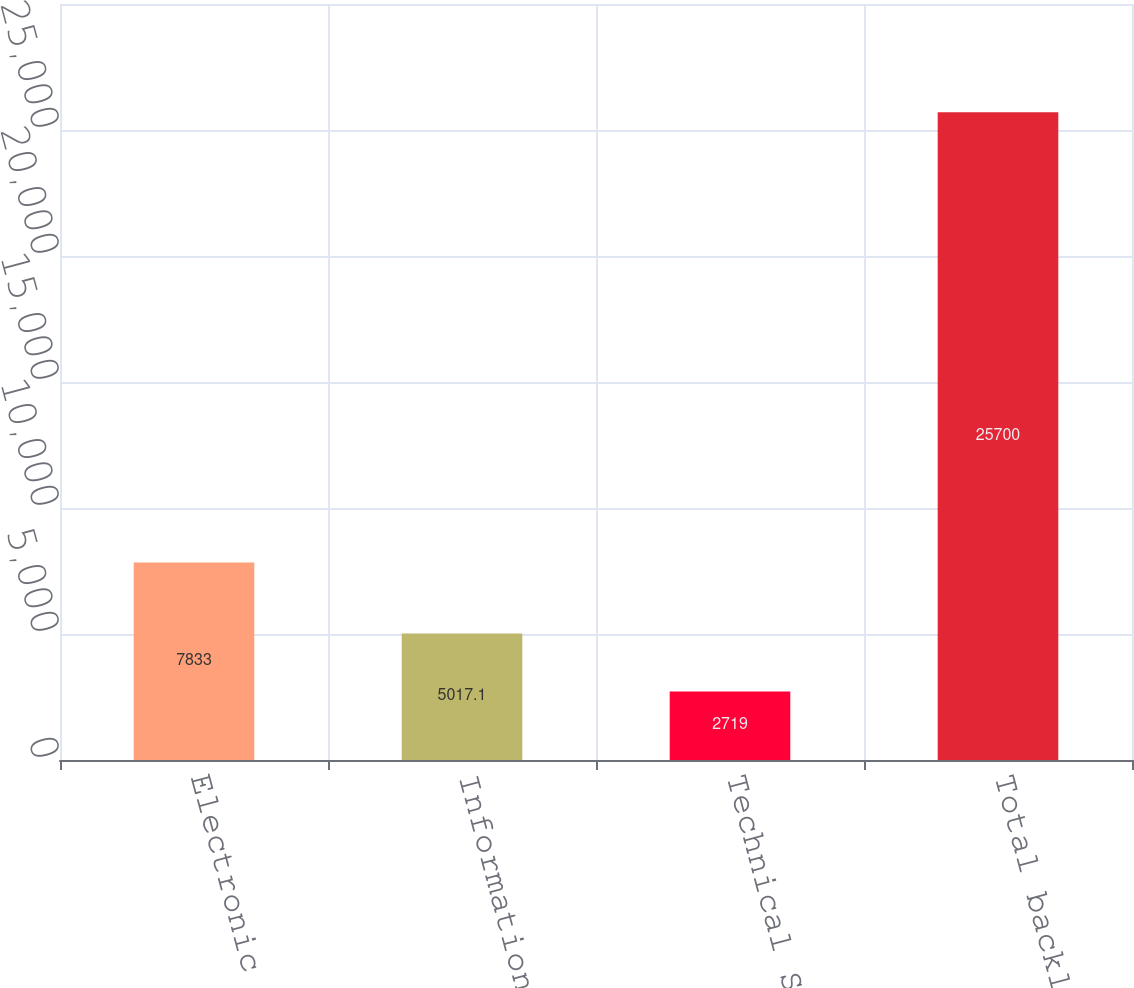<chart> <loc_0><loc_0><loc_500><loc_500><bar_chart><fcel>Electronic Systems<fcel>Information Systems<fcel>Technical Services<fcel>Total backlog<nl><fcel>7833<fcel>5017.1<fcel>2719<fcel>25700<nl></chart> 